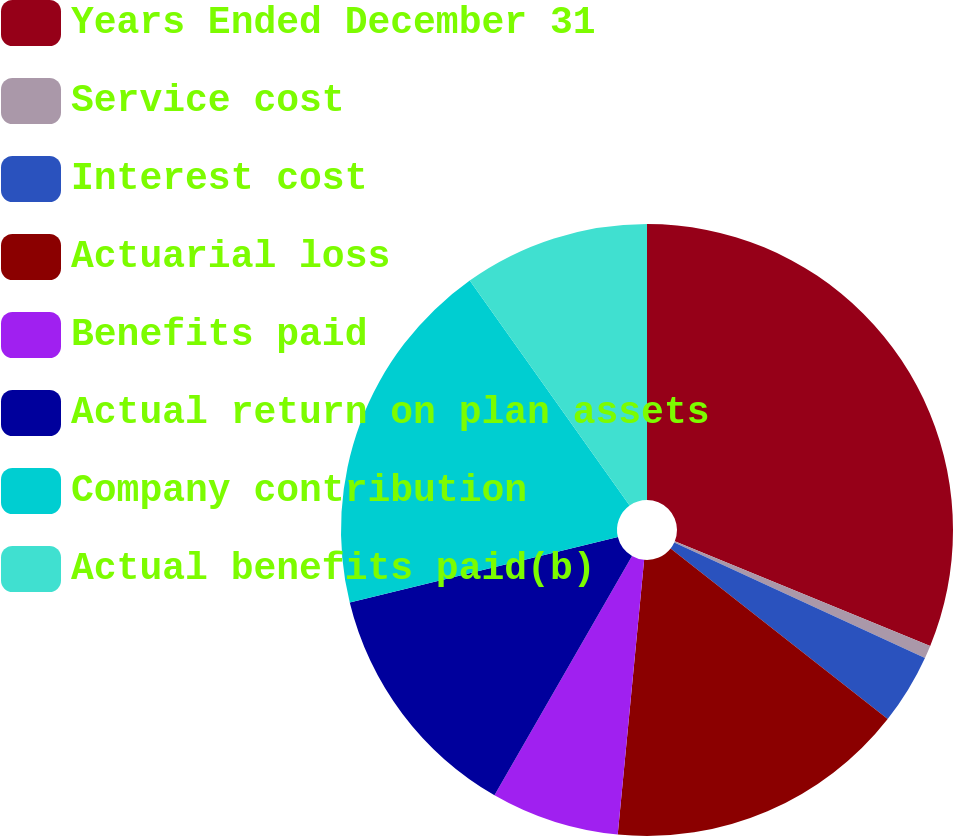Convert chart to OTSL. <chart><loc_0><loc_0><loc_500><loc_500><pie_chart><fcel>Years Ended December 31<fcel>Service cost<fcel>Interest cost<fcel>Actuarial loss<fcel>Benefits paid<fcel>Actual return on plan assets<fcel>Company contribution<fcel>Actual benefits paid(b)<nl><fcel>31.18%<fcel>0.68%<fcel>3.73%<fcel>15.93%<fcel>6.78%<fcel>12.88%<fcel>18.98%<fcel>9.83%<nl></chart> 